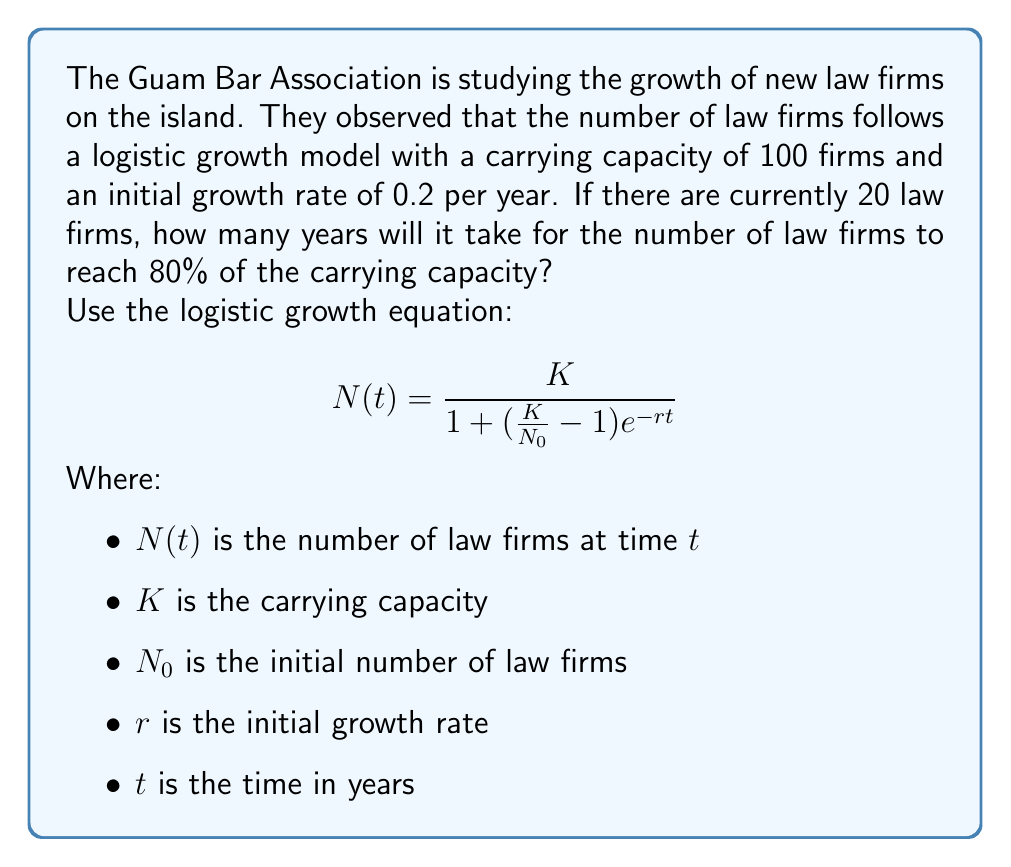Help me with this question. Let's approach this step-by-step:

1) We're given:
   $K = 100$ (carrying capacity)
   $N_0 = 20$ (initial number of law firms)
   $r = 0.2$ (initial growth rate)
   $N(t) = 0.8K = 80$ (target number of law firms, 80% of carrying capacity)

2) We need to solve for $t$ in the logistic growth equation:

   $$80 = \frac{100}{1 + (\frac{100}{20} - 1)e^{-0.2t}}$$

3) Let's simplify the right side:

   $$80 = \frac{100}{1 + (5 - 1)e^{-0.2t}} = \frac{100}{1 + 4e^{-0.2t}}$$

4) Now, let's solve for $t$:

   $$80(1 + 4e^{-0.2t}) = 100$$
   $$80 + 320e^{-0.2t} = 100$$
   $$320e^{-0.2t} = 20$$
   $$e^{-0.2t} = \frac{1}{16}$$

5) Taking the natural log of both sides:

   $$-0.2t = \ln(\frac{1}{16}) = -\ln(16)$$

6) Solving for $t$:

   $$t = \frac{\ln(16)}{0.2} \approx 13.86$$

Therefore, it will take approximately 13.86 years for the number of law firms to reach 80% of the carrying capacity.
Answer: 13.86 years 